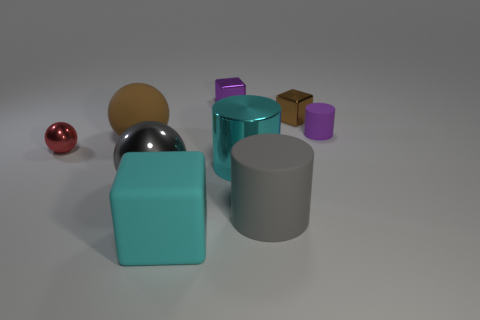Add 1 tiny purple cubes. How many objects exist? 10 Subtract all blocks. How many objects are left? 6 Add 9 brown spheres. How many brown spheres exist? 10 Subtract 0 cyan spheres. How many objects are left? 9 Subtract all big cyan matte blocks. Subtract all gray metal spheres. How many objects are left? 7 Add 2 small purple matte objects. How many small purple matte objects are left? 3 